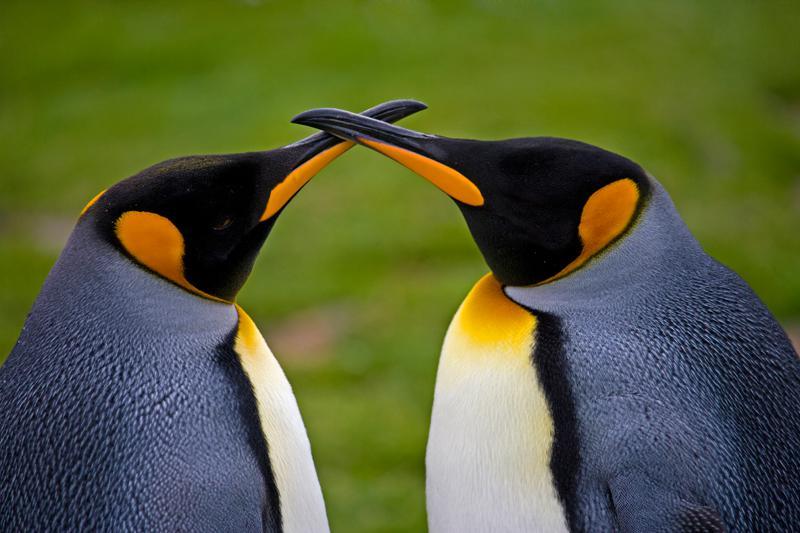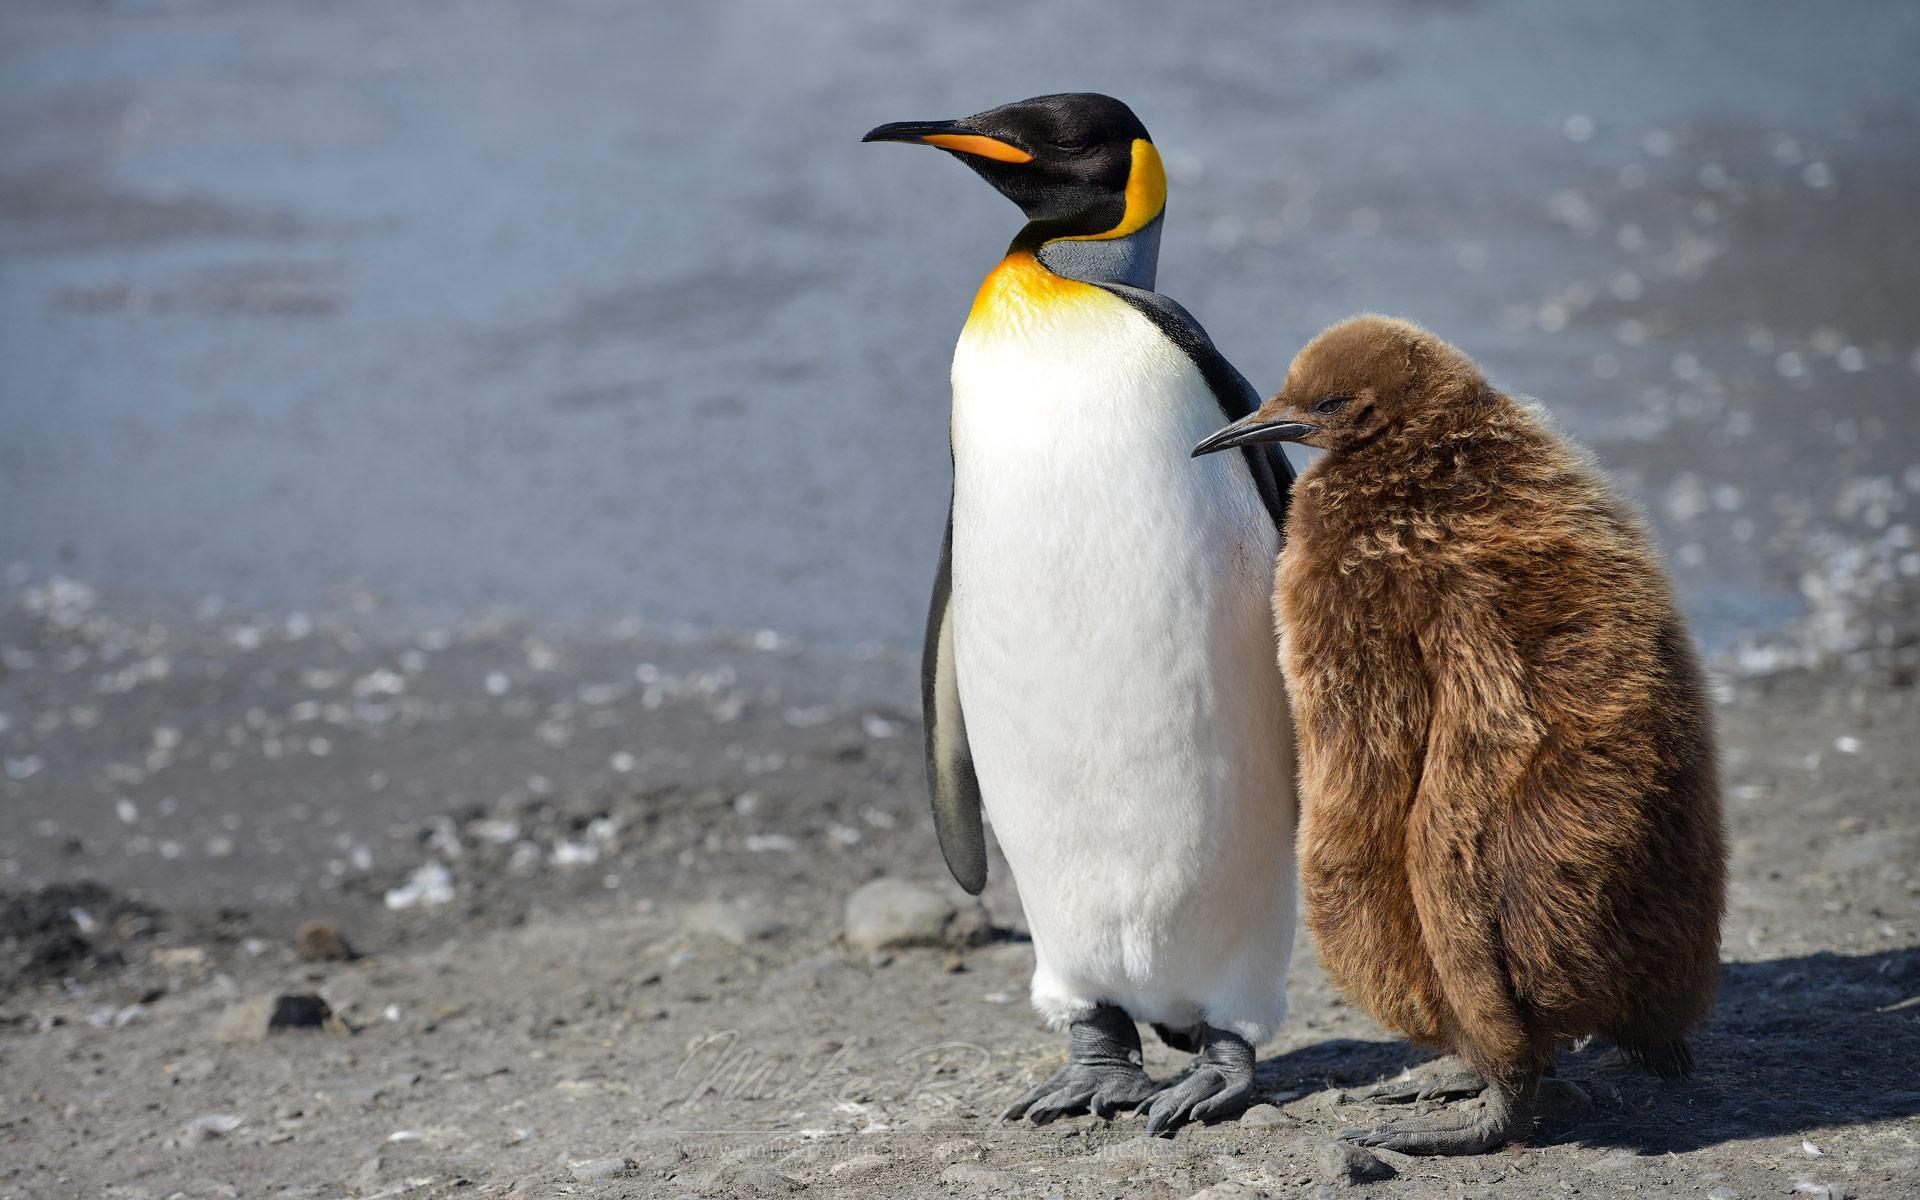The first image is the image on the left, the second image is the image on the right. Assess this claim about the two images: "There is exactly two penguins in the right image.". Correct or not? Answer yes or no. Yes. 